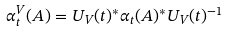Convert formula to latex. <formula><loc_0><loc_0><loc_500><loc_500>\alpha ^ { V } _ { t } ( A ) = U _ { V } ( t ) ^ { * } \alpha _ { t } ( A ) ^ { * } U _ { V } ( t ) ^ { - 1 }</formula> 